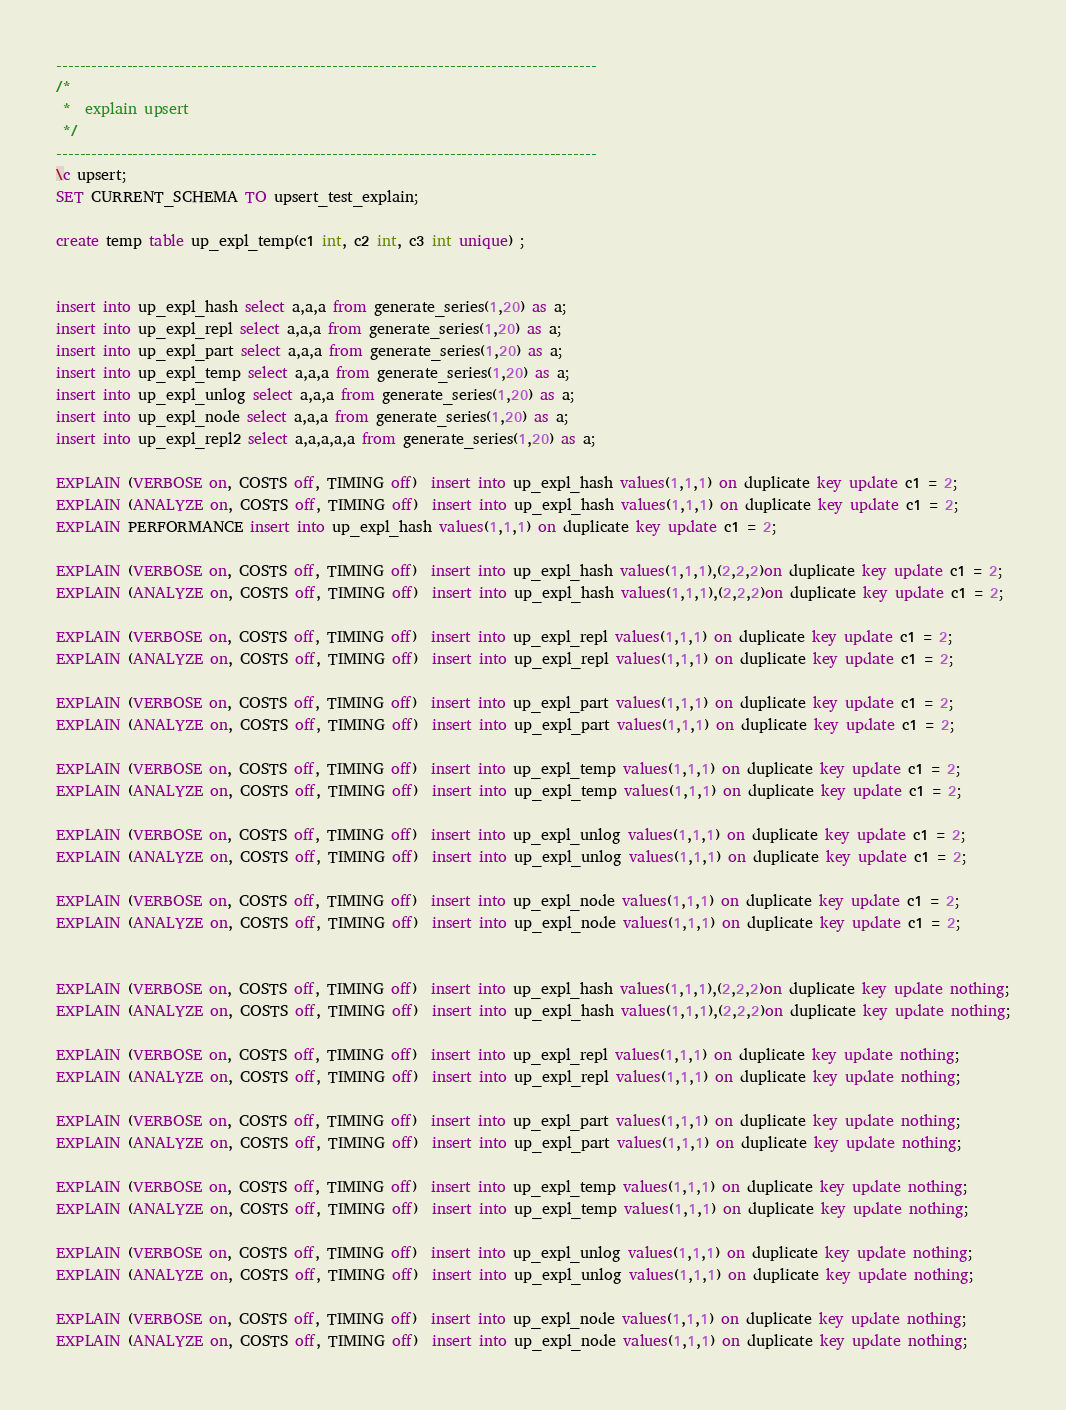Convert code to text. <code><loc_0><loc_0><loc_500><loc_500><_SQL_>--------------------------------------------------------------------------------------------
/* 
 *  explain upsert
 */
--------------------------------------------------------------------------------------------
\c upsert;
SET CURRENT_SCHEMA TO upsert_test_explain;

create temp table up_expl_temp(c1 int, c2 int, c3 int unique) ;


insert into up_expl_hash select a,a,a from generate_series(1,20) as a;
insert into up_expl_repl select a,a,a from generate_series(1,20) as a;
insert into up_expl_part select a,a,a from generate_series(1,20) as a;
insert into up_expl_temp select a,a,a from generate_series(1,20) as a;
insert into up_expl_unlog select a,a,a from generate_series(1,20) as a;
insert into up_expl_node select a,a,a from generate_series(1,20) as a;
insert into up_expl_repl2 select a,a,a,a,a from generate_series(1,20) as a;

EXPLAIN (VERBOSE on, COSTS off, TIMING off)  insert into up_expl_hash values(1,1,1) on duplicate key update c1 = 2;
EXPLAIN (ANALYZE on, COSTS off, TIMING off)  insert into up_expl_hash values(1,1,1) on duplicate key update c1 = 2;
EXPLAIN PERFORMANCE insert into up_expl_hash values(1,1,1) on duplicate key update c1 = 2;

EXPLAIN (VERBOSE on, COSTS off, TIMING off)  insert into up_expl_hash values(1,1,1),(2,2,2)on duplicate key update c1 = 2;
EXPLAIN (ANALYZE on, COSTS off, TIMING off)  insert into up_expl_hash values(1,1,1),(2,2,2)on duplicate key update c1 = 2;

EXPLAIN (VERBOSE on, COSTS off, TIMING off)  insert into up_expl_repl values(1,1,1) on duplicate key update c1 = 2;
EXPLAIN (ANALYZE on, COSTS off, TIMING off)  insert into up_expl_repl values(1,1,1) on duplicate key update c1 = 2;

EXPLAIN (VERBOSE on, COSTS off, TIMING off)  insert into up_expl_part values(1,1,1) on duplicate key update c1 = 2;
EXPLAIN (ANALYZE on, COSTS off, TIMING off)  insert into up_expl_part values(1,1,1) on duplicate key update c1 = 2;

EXPLAIN (VERBOSE on, COSTS off, TIMING off)  insert into up_expl_temp values(1,1,1) on duplicate key update c1 = 2;
EXPLAIN (ANALYZE on, COSTS off, TIMING off)  insert into up_expl_temp values(1,1,1) on duplicate key update c1 = 2;

EXPLAIN (VERBOSE on, COSTS off, TIMING off)  insert into up_expl_unlog values(1,1,1) on duplicate key update c1 = 2;
EXPLAIN (ANALYZE on, COSTS off, TIMING off)  insert into up_expl_unlog values(1,1,1) on duplicate key update c1 = 2;

EXPLAIN (VERBOSE on, COSTS off, TIMING off)  insert into up_expl_node values(1,1,1) on duplicate key update c1 = 2;
EXPLAIN (ANALYZE on, COSTS off, TIMING off)  insert into up_expl_node values(1,1,1) on duplicate key update c1 = 2;


EXPLAIN (VERBOSE on, COSTS off, TIMING off)  insert into up_expl_hash values(1,1,1),(2,2,2)on duplicate key update nothing;
EXPLAIN (ANALYZE on, COSTS off, TIMING off)  insert into up_expl_hash values(1,1,1),(2,2,2)on duplicate key update nothing;

EXPLAIN (VERBOSE on, COSTS off, TIMING off)  insert into up_expl_repl values(1,1,1) on duplicate key update nothing;
EXPLAIN (ANALYZE on, COSTS off, TIMING off)  insert into up_expl_repl values(1,1,1) on duplicate key update nothing;

EXPLAIN (VERBOSE on, COSTS off, TIMING off)  insert into up_expl_part values(1,1,1) on duplicate key update nothing;
EXPLAIN (ANALYZE on, COSTS off, TIMING off)  insert into up_expl_part values(1,1,1) on duplicate key update nothing;

EXPLAIN (VERBOSE on, COSTS off, TIMING off)  insert into up_expl_temp values(1,1,1) on duplicate key update nothing;
EXPLAIN (ANALYZE on, COSTS off, TIMING off)  insert into up_expl_temp values(1,1,1) on duplicate key update nothing;

EXPLAIN (VERBOSE on, COSTS off, TIMING off)  insert into up_expl_unlog values(1,1,1) on duplicate key update nothing;
EXPLAIN (ANALYZE on, COSTS off, TIMING off)  insert into up_expl_unlog values(1,1,1) on duplicate key update nothing;

EXPLAIN (VERBOSE on, COSTS off, TIMING off)  insert into up_expl_node values(1,1,1) on duplicate key update nothing;
EXPLAIN (ANALYZE on, COSTS off, TIMING off)  insert into up_expl_node values(1,1,1) on duplicate key update nothing;

</code> 